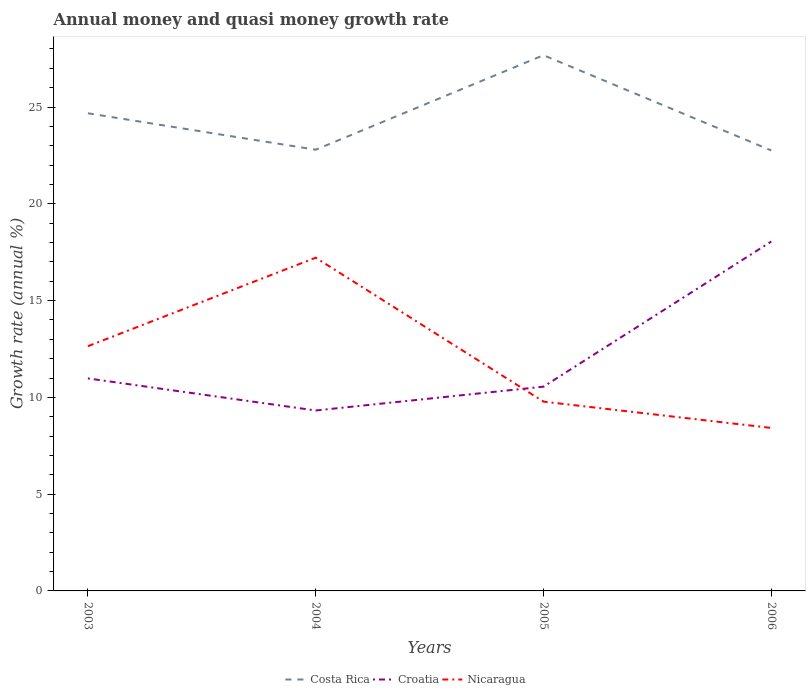Is the number of lines equal to the number of legend labels?
Provide a short and direct response. Yes. Across all years, what is the maximum growth rate in Nicaragua?
Provide a short and direct response. 8.42. In which year was the growth rate in Nicaragua maximum?
Provide a short and direct response. 2006. What is the total growth rate in Nicaragua in the graph?
Provide a short and direct response. 4.22. What is the difference between the highest and the second highest growth rate in Nicaragua?
Your answer should be very brief. 8.8. How many lines are there?
Give a very brief answer. 3. Are the values on the major ticks of Y-axis written in scientific E-notation?
Provide a short and direct response. No. Does the graph contain any zero values?
Your response must be concise. No. Does the graph contain grids?
Your answer should be compact. No. How are the legend labels stacked?
Ensure brevity in your answer.  Horizontal. What is the title of the graph?
Make the answer very short. Annual money and quasi money growth rate. Does "Brunei Darussalam" appear as one of the legend labels in the graph?
Offer a very short reply. No. What is the label or title of the X-axis?
Your response must be concise. Years. What is the label or title of the Y-axis?
Provide a succinct answer. Growth rate (annual %). What is the Growth rate (annual %) of Costa Rica in 2003?
Offer a very short reply. 24.68. What is the Growth rate (annual %) of Croatia in 2003?
Offer a very short reply. 10.98. What is the Growth rate (annual %) in Nicaragua in 2003?
Ensure brevity in your answer.  12.64. What is the Growth rate (annual %) of Costa Rica in 2004?
Keep it short and to the point. 22.79. What is the Growth rate (annual %) of Croatia in 2004?
Make the answer very short. 9.32. What is the Growth rate (annual %) of Nicaragua in 2004?
Provide a succinct answer. 17.22. What is the Growth rate (annual %) in Costa Rica in 2005?
Your answer should be very brief. 27.68. What is the Growth rate (annual %) of Croatia in 2005?
Your answer should be very brief. 10.55. What is the Growth rate (annual %) in Nicaragua in 2005?
Your response must be concise. 9.78. What is the Growth rate (annual %) in Costa Rica in 2006?
Provide a succinct answer. 22.76. What is the Growth rate (annual %) of Croatia in 2006?
Give a very brief answer. 18.05. What is the Growth rate (annual %) in Nicaragua in 2006?
Give a very brief answer. 8.42. Across all years, what is the maximum Growth rate (annual %) in Costa Rica?
Offer a very short reply. 27.68. Across all years, what is the maximum Growth rate (annual %) of Croatia?
Keep it short and to the point. 18.05. Across all years, what is the maximum Growth rate (annual %) in Nicaragua?
Make the answer very short. 17.22. Across all years, what is the minimum Growth rate (annual %) of Costa Rica?
Your answer should be compact. 22.76. Across all years, what is the minimum Growth rate (annual %) of Croatia?
Ensure brevity in your answer.  9.32. Across all years, what is the minimum Growth rate (annual %) in Nicaragua?
Offer a terse response. 8.42. What is the total Growth rate (annual %) in Costa Rica in the graph?
Make the answer very short. 97.9. What is the total Growth rate (annual %) in Croatia in the graph?
Your response must be concise. 48.91. What is the total Growth rate (annual %) in Nicaragua in the graph?
Give a very brief answer. 48.06. What is the difference between the Growth rate (annual %) in Costa Rica in 2003 and that in 2004?
Make the answer very short. 1.88. What is the difference between the Growth rate (annual %) of Croatia in 2003 and that in 2004?
Your answer should be very brief. 1.66. What is the difference between the Growth rate (annual %) of Nicaragua in 2003 and that in 2004?
Provide a succinct answer. -4.57. What is the difference between the Growth rate (annual %) of Costa Rica in 2003 and that in 2005?
Provide a short and direct response. -3. What is the difference between the Growth rate (annual %) of Croatia in 2003 and that in 2005?
Ensure brevity in your answer.  0.43. What is the difference between the Growth rate (annual %) of Nicaragua in 2003 and that in 2005?
Give a very brief answer. 2.86. What is the difference between the Growth rate (annual %) in Costa Rica in 2003 and that in 2006?
Give a very brief answer. 1.92. What is the difference between the Growth rate (annual %) in Croatia in 2003 and that in 2006?
Offer a terse response. -7.07. What is the difference between the Growth rate (annual %) of Nicaragua in 2003 and that in 2006?
Provide a succinct answer. 4.22. What is the difference between the Growth rate (annual %) of Costa Rica in 2004 and that in 2005?
Provide a succinct answer. -4.88. What is the difference between the Growth rate (annual %) in Croatia in 2004 and that in 2005?
Your answer should be compact. -1.23. What is the difference between the Growth rate (annual %) of Nicaragua in 2004 and that in 2005?
Keep it short and to the point. 7.44. What is the difference between the Growth rate (annual %) of Costa Rica in 2004 and that in 2006?
Ensure brevity in your answer.  0.04. What is the difference between the Growth rate (annual %) of Croatia in 2004 and that in 2006?
Provide a short and direct response. -8.73. What is the difference between the Growth rate (annual %) in Nicaragua in 2004 and that in 2006?
Make the answer very short. 8.8. What is the difference between the Growth rate (annual %) of Costa Rica in 2005 and that in 2006?
Your response must be concise. 4.92. What is the difference between the Growth rate (annual %) in Croatia in 2005 and that in 2006?
Your answer should be compact. -7.5. What is the difference between the Growth rate (annual %) of Nicaragua in 2005 and that in 2006?
Offer a terse response. 1.36. What is the difference between the Growth rate (annual %) in Costa Rica in 2003 and the Growth rate (annual %) in Croatia in 2004?
Your answer should be very brief. 15.35. What is the difference between the Growth rate (annual %) of Costa Rica in 2003 and the Growth rate (annual %) of Nicaragua in 2004?
Provide a short and direct response. 7.46. What is the difference between the Growth rate (annual %) of Croatia in 2003 and the Growth rate (annual %) of Nicaragua in 2004?
Keep it short and to the point. -6.24. What is the difference between the Growth rate (annual %) in Costa Rica in 2003 and the Growth rate (annual %) in Croatia in 2005?
Your answer should be very brief. 14.12. What is the difference between the Growth rate (annual %) of Costa Rica in 2003 and the Growth rate (annual %) of Nicaragua in 2005?
Keep it short and to the point. 14.9. What is the difference between the Growth rate (annual %) in Croatia in 2003 and the Growth rate (annual %) in Nicaragua in 2005?
Keep it short and to the point. 1.2. What is the difference between the Growth rate (annual %) in Costa Rica in 2003 and the Growth rate (annual %) in Croatia in 2006?
Provide a short and direct response. 6.62. What is the difference between the Growth rate (annual %) of Costa Rica in 2003 and the Growth rate (annual %) of Nicaragua in 2006?
Keep it short and to the point. 16.26. What is the difference between the Growth rate (annual %) in Croatia in 2003 and the Growth rate (annual %) in Nicaragua in 2006?
Your answer should be compact. 2.56. What is the difference between the Growth rate (annual %) of Costa Rica in 2004 and the Growth rate (annual %) of Croatia in 2005?
Your answer should be compact. 12.24. What is the difference between the Growth rate (annual %) in Costa Rica in 2004 and the Growth rate (annual %) in Nicaragua in 2005?
Make the answer very short. 13.01. What is the difference between the Growth rate (annual %) in Croatia in 2004 and the Growth rate (annual %) in Nicaragua in 2005?
Make the answer very short. -0.46. What is the difference between the Growth rate (annual %) in Costa Rica in 2004 and the Growth rate (annual %) in Croatia in 2006?
Offer a very short reply. 4.74. What is the difference between the Growth rate (annual %) in Costa Rica in 2004 and the Growth rate (annual %) in Nicaragua in 2006?
Your answer should be very brief. 14.37. What is the difference between the Growth rate (annual %) in Croatia in 2004 and the Growth rate (annual %) in Nicaragua in 2006?
Keep it short and to the point. 0.9. What is the difference between the Growth rate (annual %) in Costa Rica in 2005 and the Growth rate (annual %) in Croatia in 2006?
Keep it short and to the point. 9.62. What is the difference between the Growth rate (annual %) in Costa Rica in 2005 and the Growth rate (annual %) in Nicaragua in 2006?
Provide a short and direct response. 19.26. What is the difference between the Growth rate (annual %) of Croatia in 2005 and the Growth rate (annual %) of Nicaragua in 2006?
Your answer should be very brief. 2.13. What is the average Growth rate (annual %) in Costa Rica per year?
Provide a short and direct response. 24.48. What is the average Growth rate (annual %) of Croatia per year?
Your answer should be compact. 12.23. What is the average Growth rate (annual %) of Nicaragua per year?
Your answer should be very brief. 12.01. In the year 2003, what is the difference between the Growth rate (annual %) in Costa Rica and Growth rate (annual %) in Croatia?
Provide a succinct answer. 13.7. In the year 2003, what is the difference between the Growth rate (annual %) of Costa Rica and Growth rate (annual %) of Nicaragua?
Provide a short and direct response. 12.03. In the year 2003, what is the difference between the Growth rate (annual %) in Croatia and Growth rate (annual %) in Nicaragua?
Provide a succinct answer. -1.66. In the year 2004, what is the difference between the Growth rate (annual %) in Costa Rica and Growth rate (annual %) in Croatia?
Offer a very short reply. 13.47. In the year 2004, what is the difference between the Growth rate (annual %) in Costa Rica and Growth rate (annual %) in Nicaragua?
Your answer should be compact. 5.58. In the year 2004, what is the difference between the Growth rate (annual %) in Croatia and Growth rate (annual %) in Nicaragua?
Provide a short and direct response. -7.89. In the year 2005, what is the difference between the Growth rate (annual %) in Costa Rica and Growth rate (annual %) in Croatia?
Provide a short and direct response. 17.12. In the year 2005, what is the difference between the Growth rate (annual %) in Costa Rica and Growth rate (annual %) in Nicaragua?
Make the answer very short. 17.9. In the year 2005, what is the difference between the Growth rate (annual %) of Croatia and Growth rate (annual %) of Nicaragua?
Offer a terse response. 0.77. In the year 2006, what is the difference between the Growth rate (annual %) of Costa Rica and Growth rate (annual %) of Croatia?
Provide a succinct answer. 4.7. In the year 2006, what is the difference between the Growth rate (annual %) of Costa Rica and Growth rate (annual %) of Nicaragua?
Provide a short and direct response. 14.34. In the year 2006, what is the difference between the Growth rate (annual %) of Croatia and Growth rate (annual %) of Nicaragua?
Keep it short and to the point. 9.63. What is the ratio of the Growth rate (annual %) of Costa Rica in 2003 to that in 2004?
Keep it short and to the point. 1.08. What is the ratio of the Growth rate (annual %) in Croatia in 2003 to that in 2004?
Your answer should be compact. 1.18. What is the ratio of the Growth rate (annual %) of Nicaragua in 2003 to that in 2004?
Keep it short and to the point. 0.73. What is the ratio of the Growth rate (annual %) in Costa Rica in 2003 to that in 2005?
Keep it short and to the point. 0.89. What is the ratio of the Growth rate (annual %) in Croatia in 2003 to that in 2005?
Keep it short and to the point. 1.04. What is the ratio of the Growth rate (annual %) in Nicaragua in 2003 to that in 2005?
Your response must be concise. 1.29. What is the ratio of the Growth rate (annual %) of Costa Rica in 2003 to that in 2006?
Keep it short and to the point. 1.08. What is the ratio of the Growth rate (annual %) in Croatia in 2003 to that in 2006?
Give a very brief answer. 0.61. What is the ratio of the Growth rate (annual %) of Nicaragua in 2003 to that in 2006?
Give a very brief answer. 1.5. What is the ratio of the Growth rate (annual %) of Costa Rica in 2004 to that in 2005?
Your answer should be very brief. 0.82. What is the ratio of the Growth rate (annual %) in Croatia in 2004 to that in 2005?
Ensure brevity in your answer.  0.88. What is the ratio of the Growth rate (annual %) of Nicaragua in 2004 to that in 2005?
Ensure brevity in your answer.  1.76. What is the ratio of the Growth rate (annual %) of Croatia in 2004 to that in 2006?
Give a very brief answer. 0.52. What is the ratio of the Growth rate (annual %) in Nicaragua in 2004 to that in 2006?
Provide a succinct answer. 2.04. What is the ratio of the Growth rate (annual %) in Costa Rica in 2005 to that in 2006?
Offer a very short reply. 1.22. What is the ratio of the Growth rate (annual %) of Croatia in 2005 to that in 2006?
Your answer should be compact. 0.58. What is the ratio of the Growth rate (annual %) in Nicaragua in 2005 to that in 2006?
Provide a short and direct response. 1.16. What is the difference between the highest and the second highest Growth rate (annual %) of Costa Rica?
Offer a very short reply. 3. What is the difference between the highest and the second highest Growth rate (annual %) in Croatia?
Your answer should be compact. 7.07. What is the difference between the highest and the second highest Growth rate (annual %) of Nicaragua?
Keep it short and to the point. 4.57. What is the difference between the highest and the lowest Growth rate (annual %) of Costa Rica?
Offer a terse response. 4.92. What is the difference between the highest and the lowest Growth rate (annual %) in Croatia?
Your response must be concise. 8.73. What is the difference between the highest and the lowest Growth rate (annual %) in Nicaragua?
Make the answer very short. 8.8. 